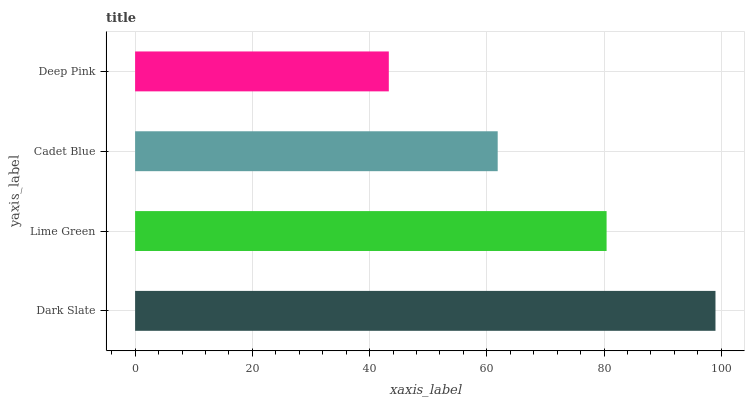Is Deep Pink the minimum?
Answer yes or no. Yes. Is Dark Slate the maximum?
Answer yes or no. Yes. Is Lime Green the minimum?
Answer yes or no. No. Is Lime Green the maximum?
Answer yes or no. No. Is Dark Slate greater than Lime Green?
Answer yes or no. Yes. Is Lime Green less than Dark Slate?
Answer yes or no. Yes. Is Lime Green greater than Dark Slate?
Answer yes or no. No. Is Dark Slate less than Lime Green?
Answer yes or no. No. Is Lime Green the high median?
Answer yes or no. Yes. Is Cadet Blue the low median?
Answer yes or no. Yes. Is Deep Pink the high median?
Answer yes or no. No. Is Lime Green the low median?
Answer yes or no. No. 